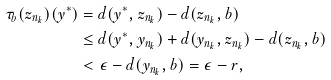Convert formula to latex. <formula><loc_0><loc_0><loc_500><loc_500>\tau _ { b } ( z _ { n _ { k } } ) ( y ^ { * } ) & = d ( y ^ { * } , z _ { n _ { k } } ) - d ( z _ { n _ { k } } , b ) \\ & \leq d ( y ^ { * } , y _ { n _ { k } } ) + d ( y _ { n _ { k } } , z _ { n _ { k } } ) - d ( z _ { n _ { k } } , b ) \\ & < \epsilon - d ( y _ { n _ { k } } , b ) = \epsilon - r ,</formula> 